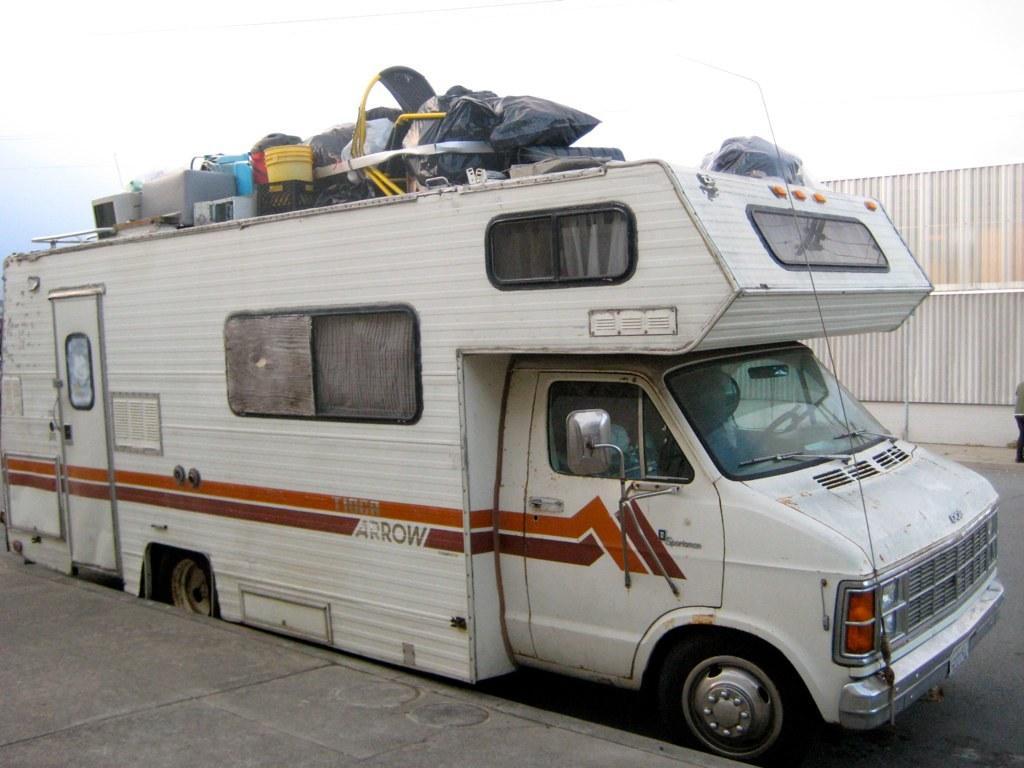In one or two sentences, can you explain what this image depicts? In front of the image there is a pavement. There is a vehicle on the road. On top of the vehicle there are some objects. In the background of the image there is a person standing. Behind him there is a wall. At the top of the image there is sky. 